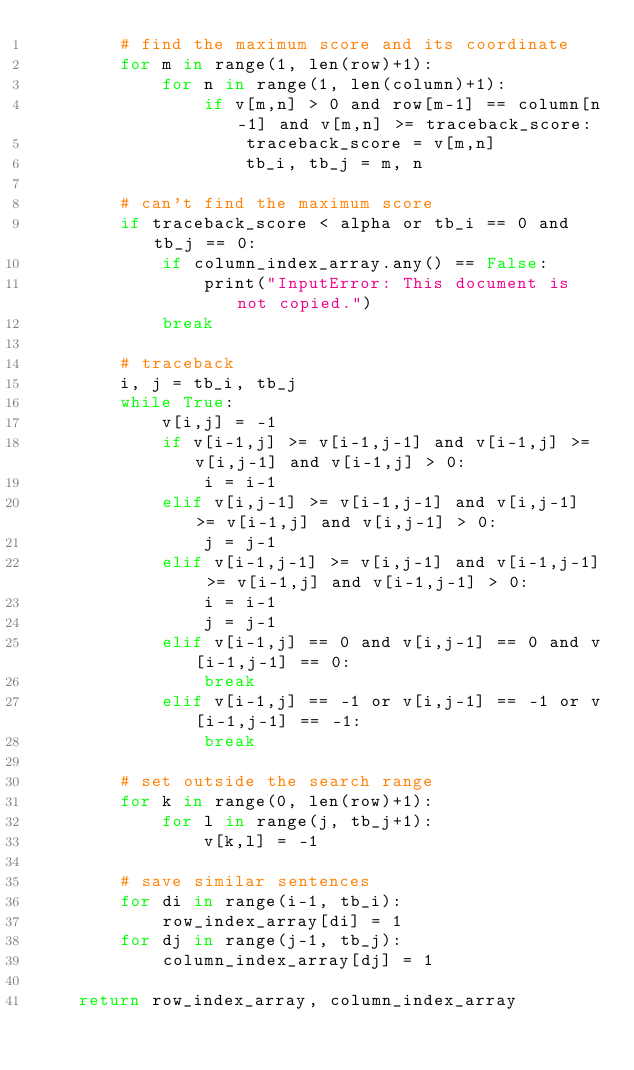Convert code to text. <code><loc_0><loc_0><loc_500><loc_500><_Cython_>        # find the maximum score and its coordinate
        for m in range(1, len(row)+1):
            for n in range(1, len(column)+1):
                if v[m,n] > 0 and row[m-1] == column[n-1] and v[m,n] >= traceback_score:
                    traceback_score = v[m,n]
                    tb_i, tb_j = m, n

        # can't find the maximum score
        if traceback_score < alpha or tb_i == 0 and tb_j == 0:
            if column_index_array.any() == False:
                print("InputError: This document is not copied.")
            break

        # traceback
        i, j = tb_i, tb_j
        while True:
            v[i,j] = -1
            if v[i-1,j] >= v[i-1,j-1] and v[i-1,j] >= v[i,j-1] and v[i-1,j] > 0:
                i = i-1
            elif v[i,j-1] >= v[i-1,j-1] and v[i,j-1] >= v[i-1,j] and v[i,j-1] > 0:
                j = j-1
            elif v[i-1,j-1] >= v[i,j-1] and v[i-1,j-1] >= v[i-1,j] and v[i-1,j-1] > 0:
                i = i-1
                j = j-1
            elif v[i-1,j] == 0 and v[i,j-1] == 0 and v[i-1,j-1] == 0:
                break
            elif v[i-1,j] == -1 or v[i,j-1] == -1 or v[i-1,j-1] == -1:
                break

        # set outside the search range
        for k in range(0, len(row)+1):
            for l in range(j, tb_j+1):
                v[k,l] = -1

        # save similar sentences
        for di in range(i-1, tb_i):
            row_index_array[di] = 1
        for dj in range(j-1, tb_j):
            column_index_array[dj] = 1

    return row_index_array, column_index_array
</code> 